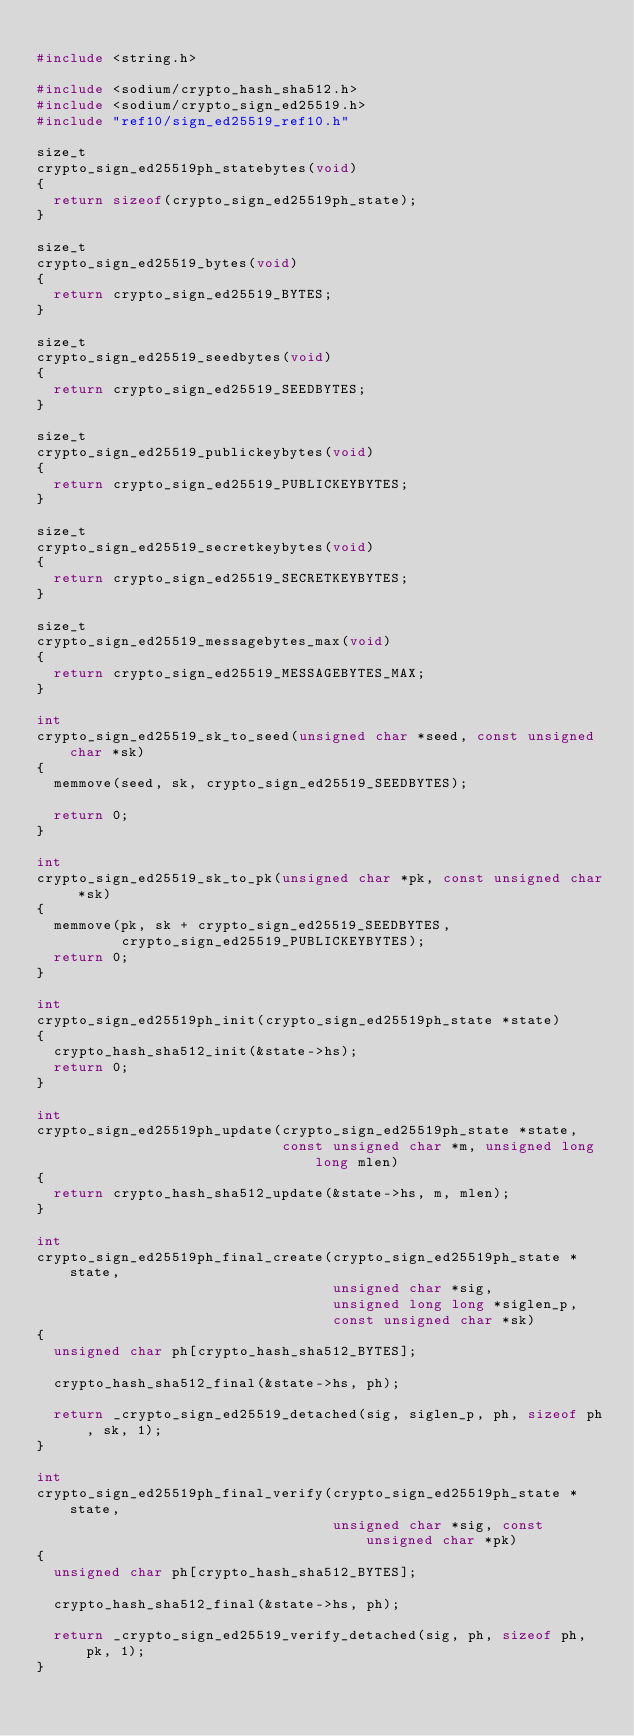Convert code to text. <code><loc_0><loc_0><loc_500><loc_500><_C_>
#include <string.h>

#include <sodium/crypto_hash_sha512.h>
#include <sodium/crypto_sign_ed25519.h>
#include "ref10/sign_ed25519_ref10.h"

size_t
crypto_sign_ed25519ph_statebytes(void)
{
  return sizeof(crypto_sign_ed25519ph_state);
}

size_t
crypto_sign_ed25519_bytes(void)
{
  return crypto_sign_ed25519_BYTES;
}

size_t
crypto_sign_ed25519_seedbytes(void)
{
  return crypto_sign_ed25519_SEEDBYTES;
}

size_t
crypto_sign_ed25519_publickeybytes(void)
{
  return crypto_sign_ed25519_PUBLICKEYBYTES;
}

size_t
crypto_sign_ed25519_secretkeybytes(void)
{
  return crypto_sign_ed25519_SECRETKEYBYTES;
}

size_t
crypto_sign_ed25519_messagebytes_max(void)
{
  return crypto_sign_ed25519_MESSAGEBYTES_MAX;
}

int
crypto_sign_ed25519_sk_to_seed(unsigned char *seed, const unsigned char *sk)
{
  memmove(seed, sk, crypto_sign_ed25519_SEEDBYTES);

  return 0;
}

int
crypto_sign_ed25519_sk_to_pk(unsigned char *pk, const unsigned char *sk)
{
  memmove(pk, sk + crypto_sign_ed25519_SEEDBYTES,
          crypto_sign_ed25519_PUBLICKEYBYTES);
  return 0;
}

int
crypto_sign_ed25519ph_init(crypto_sign_ed25519ph_state *state)
{
  crypto_hash_sha512_init(&state->hs);
  return 0;
}

int
crypto_sign_ed25519ph_update(crypto_sign_ed25519ph_state *state,
                             const unsigned char *m, unsigned long long mlen)
{
  return crypto_hash_sha512_update(&state->hs, m, mlen);
}

int
crypto_sign_ed25519ph_final_create(crypto_sign_ed25519ph_state *state,
                                   unsigned char *sig,
                                   unsigned long long *siglen_p,
                                   const unsigned char *sk)
{
  unsigned char ph[crypto_hash_sha512_BYTES];

  crypto_hash_sha512_final(&state->hs, ph);

  return _crypto_sign_ed25519_detached(sig, siglen_p, ph, sizeof ph, sk, 1);
}

int
crypto_sign_ed25519ph_final_verify(crypto_sign_ed25519ph_state *state,
                                   unsigned char *sig, const unsigned char *pk)
{
  unsigned char ph[crypto_hash_sha512_BYTES];

  crypto_hash_sha512_final(&state->hs, ph);

  return _crypto_sign_ed25519_verify_detached(sig, ph, sizeof ph, pk, 1);
}
</code> 